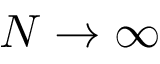<formula> <loc_0><loc_0><loc_500><loc_500>N \rightarrow \infty</formula> 